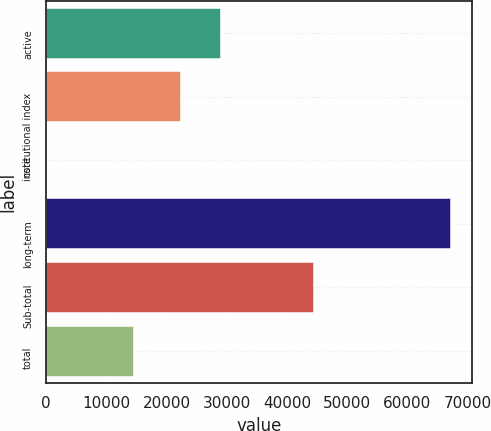Convert chart. <chart><loc_0><loc_0><loc_500><loc_500><bar_chart><fcel>active<fcel>institutional index<fcel>core<fcel>long-term<fcel>Sub-total<fcel>total<nl><fcel>29133.1<fcel>22403<fcel>48<fcel>67349<fcel>44450<fcel>14547<nl></chart> 